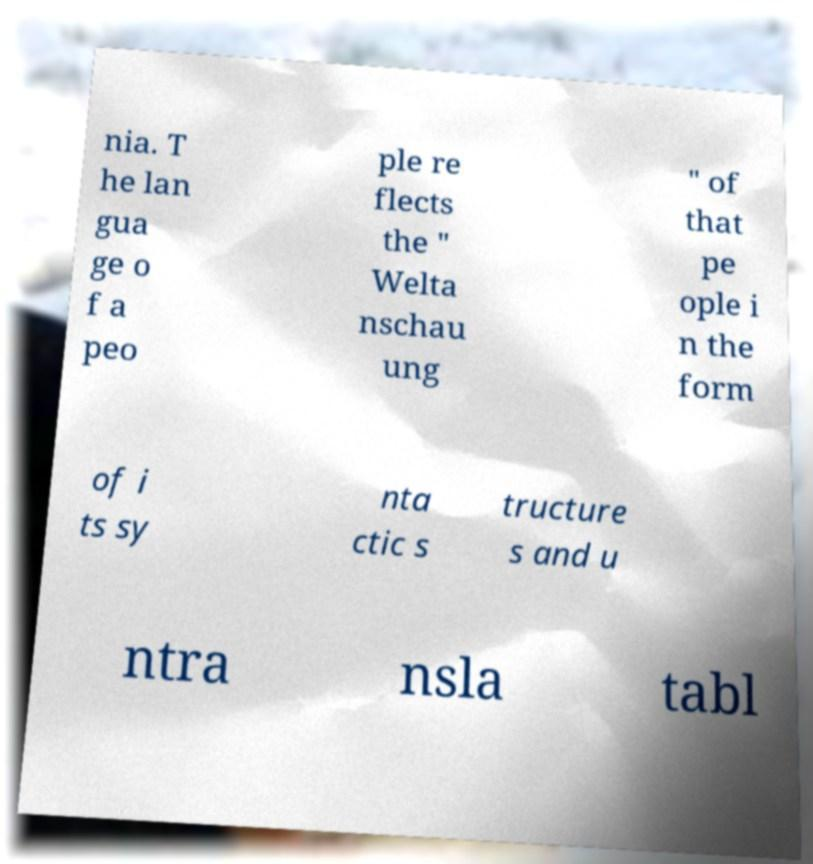There's text embedded in this image that I need extracted. Can you transcribe it verbatim? nia. T he lan gua ge o f a peo ple re flects the " Welta nschau ung " of that pe ople i n the form of i ts sy nta ctic s tructure s and u ntra nsla tabl 